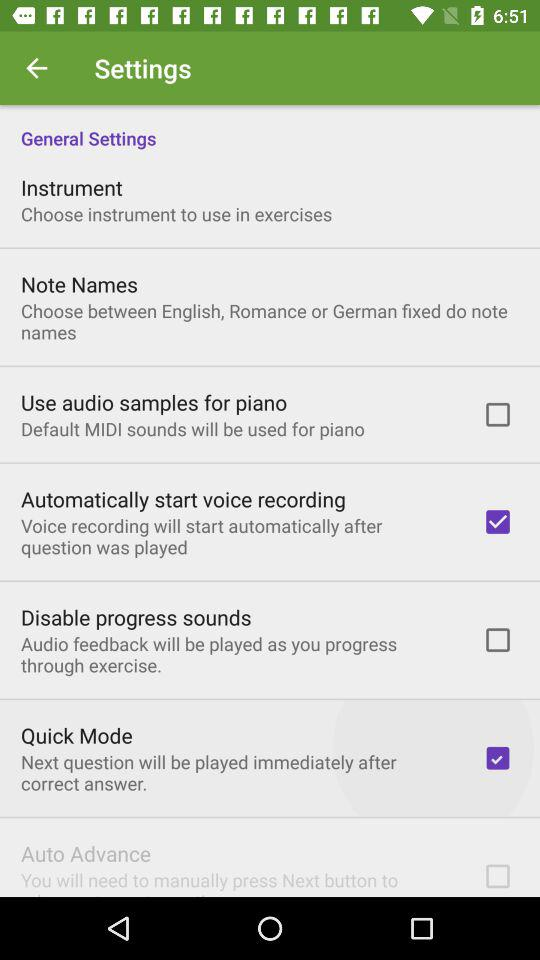What is the status of "Disable progress sounds"? The status is "off". 